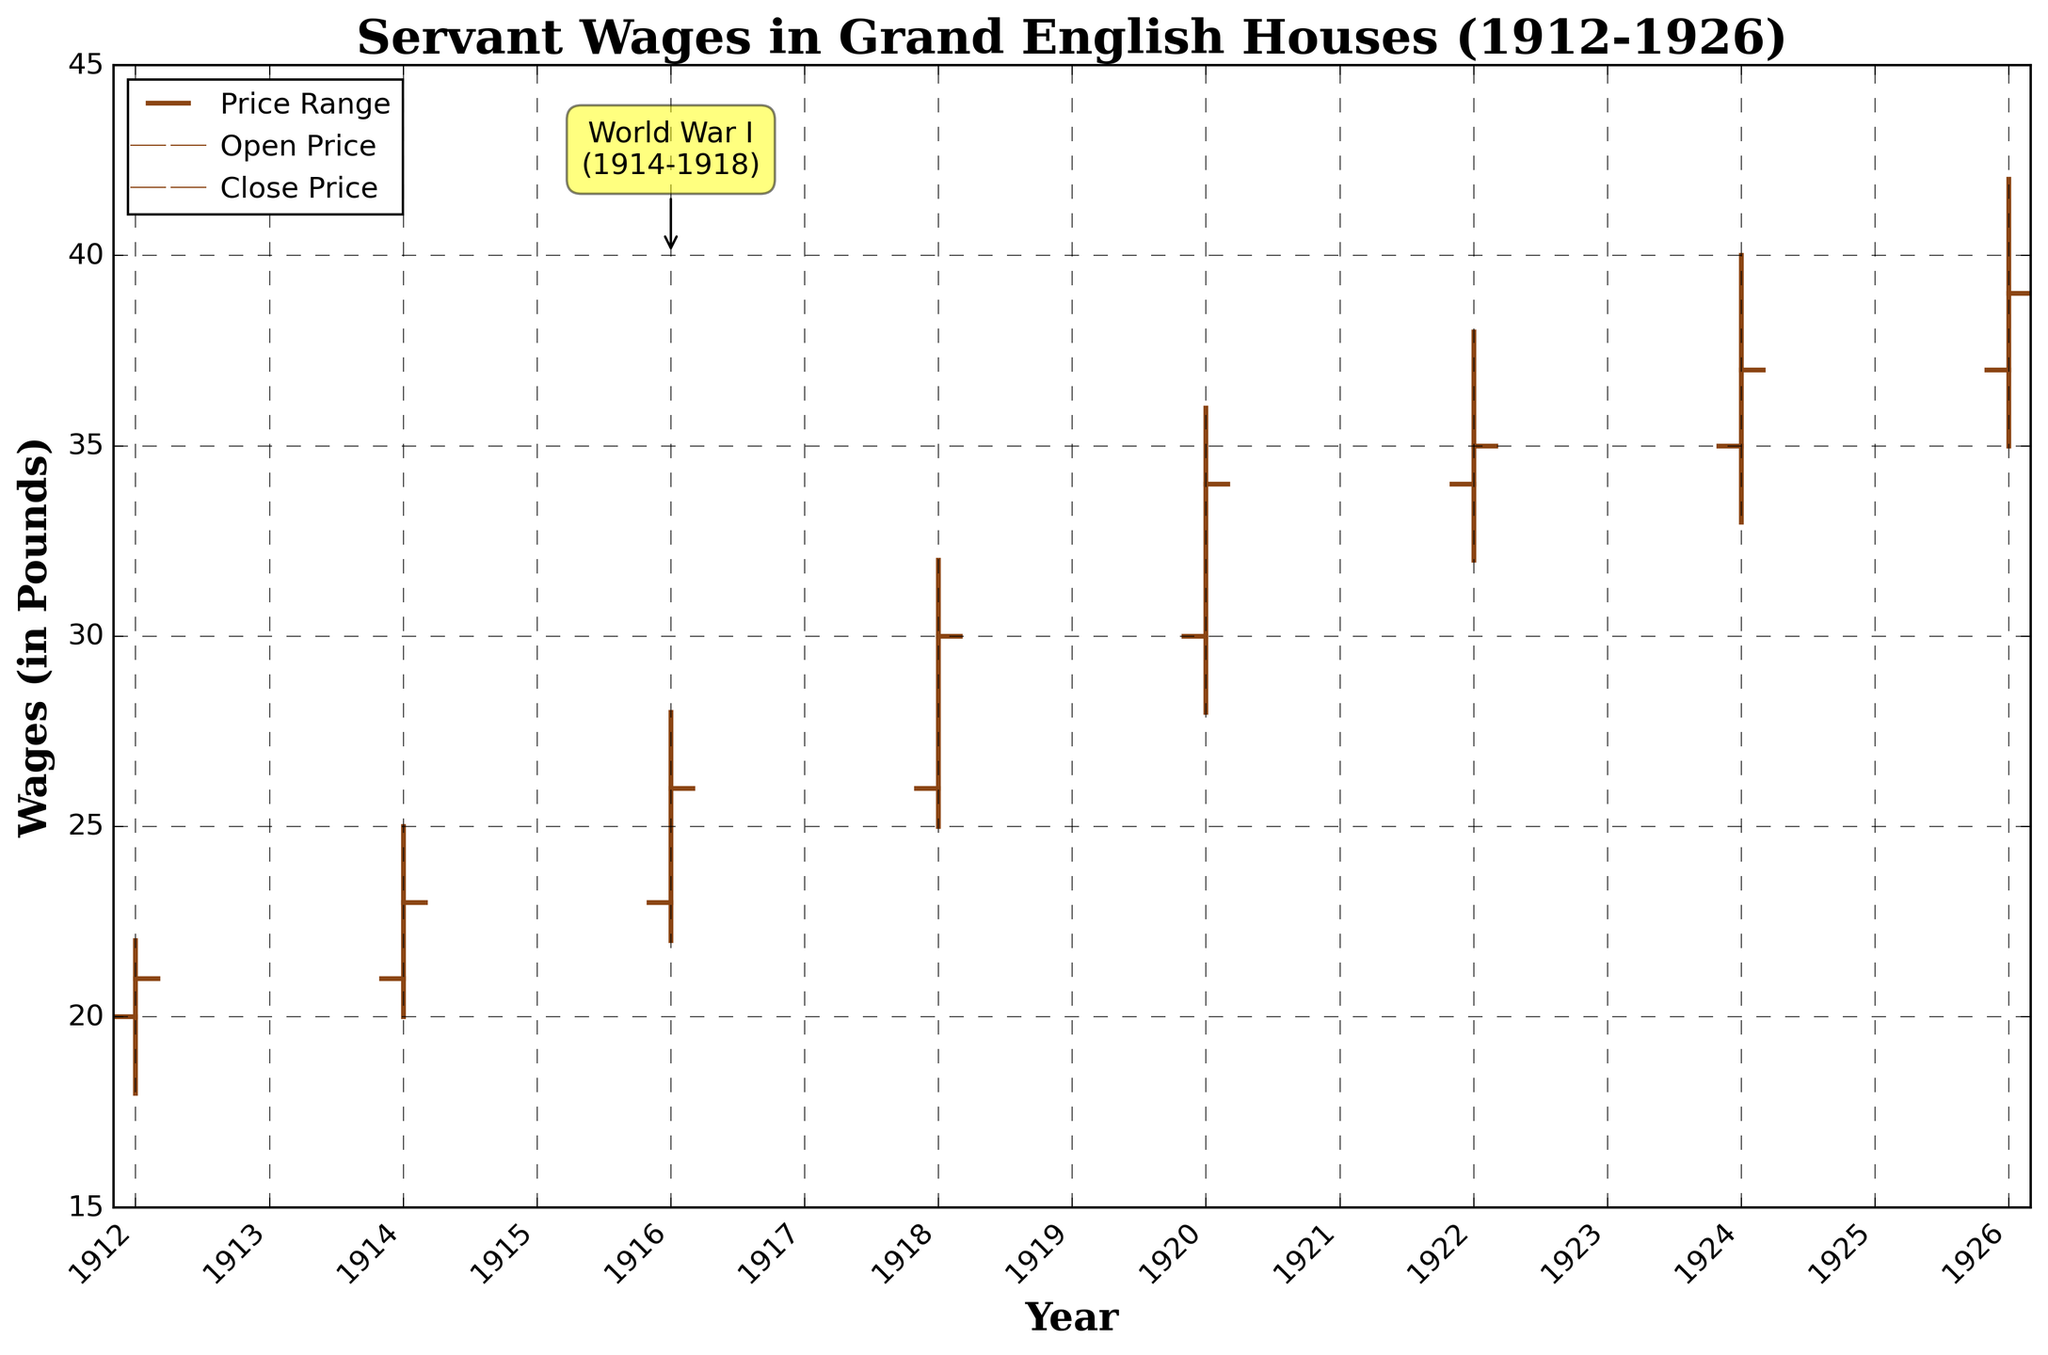What is the title of the figure? The title is visible at the top of the figure and reads "Servant Wages in Grand English Houses (1912-1926)".
Answer: Servant Wages in Grand English Houses (1912-1926) How many data points are plotted on the figure? There are vertical lines representing each year with wages indicated by High, Low, Open, and Close prices. Each year from 1912 to 1926 has one data point, creating a total of 8 data points.
Answer: 8 What is the highest wage recorded on the figure and in which year? The highest wage is represented by the topmost point of any vertical line. The highest point is at 42 pounds in the year 1926.
Answer: 42 in 1926 Which year had the lowest "Low" wage and what was it? The lowest "Low" wage can be identified by the bottom end of the vertical lines. The lowest "Low" wage is 18 pounds in the year 1912.
Answer: 18 in 1912 During what period did the wage increase the most between consecutive years? To find the period with the highest wage increase, look at the difference between the high points or closing prices of consecutive years. The biggest increase in closing prices occurs between 1918 (30 pounds) and 1920 (34 pounds), a 4-pound increase.
Answer: 1918 to 1920 Which years are encompassed within the shaded annotation indicating World War I? The annotation labeled "World War I" spans the years 1914 to 1918.
Answer: 1914 to 1918 What is the median of the 'Close' wages across all years? The 'Close' wages are 21, 23, 26, 30, 34, 35, 37, and 39. Arranging them in ascending order, the midpoint values are 30 and 34, so the median is the average of these two: (30 + 34) / 2 = 32.
Answer: 32 How did the "Open" wage in 1914 compare to the "Close" wage in 1926? The "Open" wage for 1914 is 21 pounds, and the "Close" wage for 1926 is 39 pounds. Comparatively, the "Close" wage in 1926 is higher by 18 pounds.
Answer: 1926 Close wage is higher by 18 pounds What can we infer about the trend of wages from 1912 to 1926? By observing the generally increasing trend as indicated by the OHLC bars with higher openings, closings, highs, and lows, wages for servants in grand English houses consistently increased from 1912 to 1926.
Answer: Wages consistently increased 